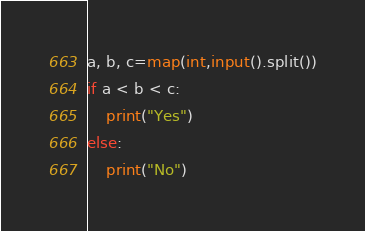<code> <loc_0><loc_0><loc_500><loc_500><_Python_>a, b, c=map(int,input().split())
if a < b < c:
    print("Yes")
else: 
    print("No")
</code> 